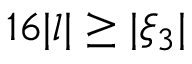<formula> <loc_0><loc_0><loc_500><loc_500>1 6 | l | \geq | \xi _ { 3 } |</formula> 